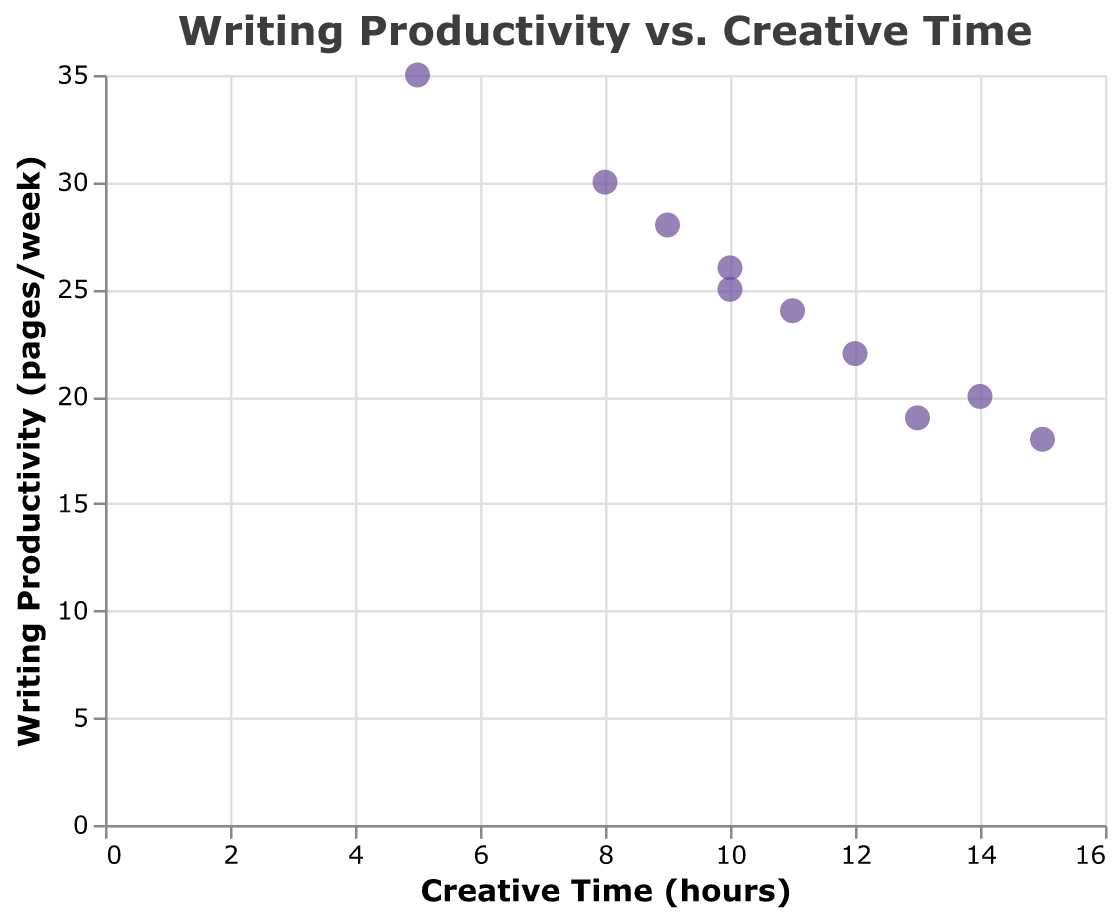What is the title of the figure? The title is usually placed at the top of the figure. Here, it reads "Writing Productivity vs. Creative Time."
Answer: Writing Productivity vs. Creative Time How many authors are represented in the scatter plot? Each data point represents one author. Counting these points reveals the total number.
Answer: 10 What color are the data points in the scatter plot? The color of the points is visually noticeable and in this case is described as "#6b4c9a", which appears as a shade of purple.
Answer: Purple Which author has the highest weekly writing productivity? By locating the highest point on the y-axis (Writing Productivity) and checking the tooltip, we find that Jessica Brown has the highest value.
Answer: Jessica Brown What is the weekly writing productivity of Alice Smith? Hovering over Alice Smith's point or checking its location on the y-axis provides this value.
Answer: 25 pages Which author spends the most time on creative activities? By locating the farthest point on the x-axis (Creative Time), we find that Emily Johnson spends the most time.
Answer: Emily Johnson How much time does Michael Williams spend on creative activities? Hovering over Michael Williams's point or checking its location on the x-axis provides the value.
Answer: 12 hours What is the average weekly writing productivity among all authors? Adding the productivity values (25 + 30 + 18 + 22 + 35 + 20 + 28 + 24 + 26 + 19) gives 247 pages/week in total. Dividing by 10 authors gives the average.
Answer: 24.7 pages Is there any clear correlation between time spent on creative activities and writing productivity? Evaluating the pattern of the scatter plot, if most points slope upwards or downwards, but in this case, the dispersion appears random with no clear trend.
Answer: No clear correlation 